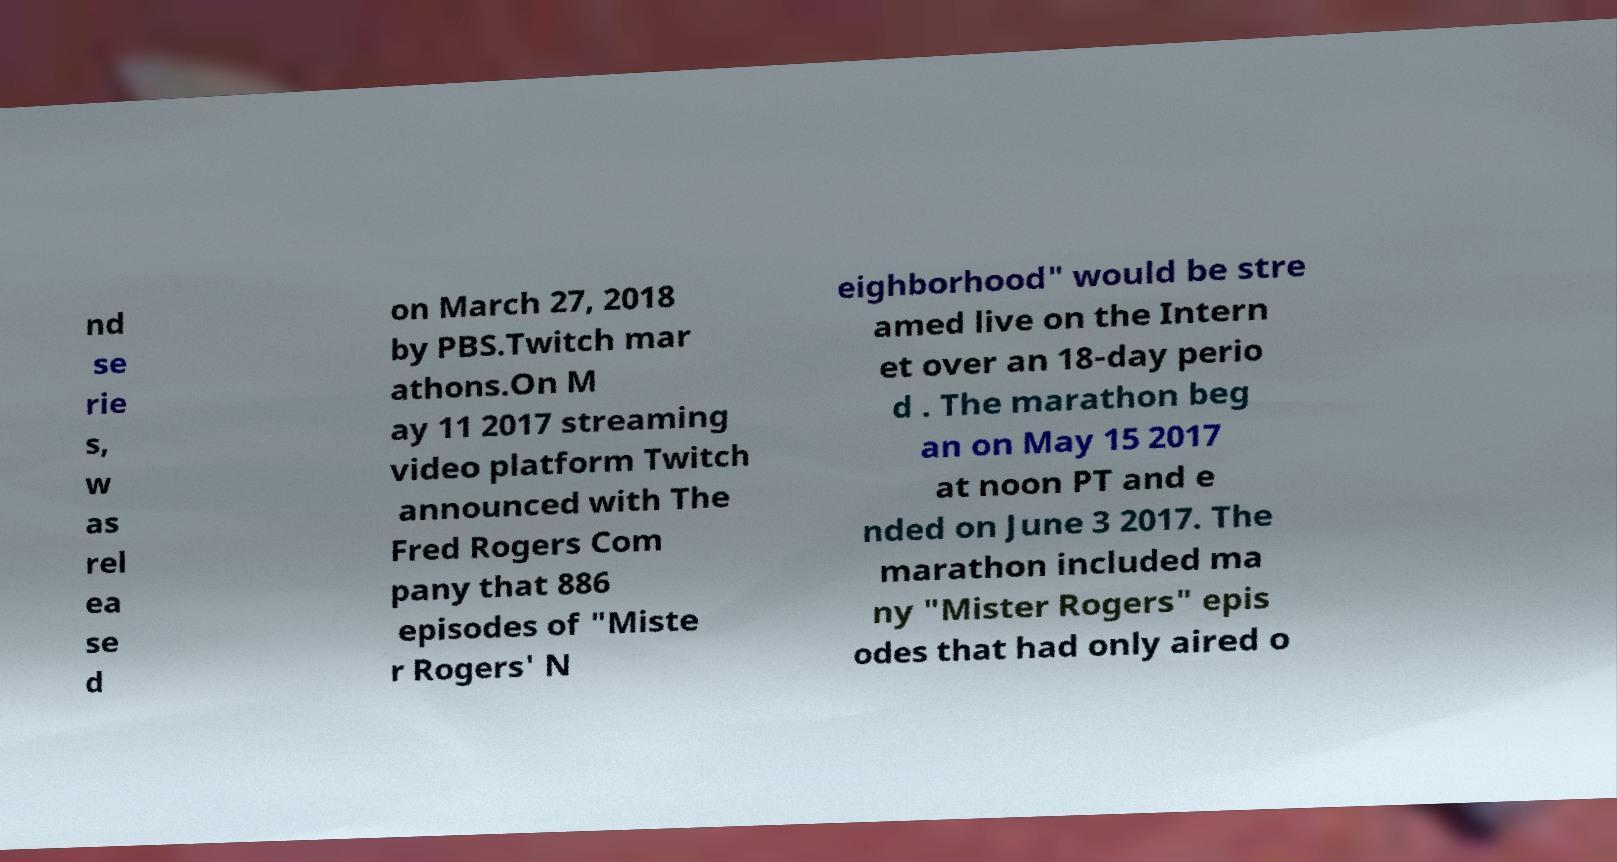I need the written content from this picture converted into text. Can you do that? nd se rie s, w as rel ea se d on March 27, 2018 by PBS.Twitch mar athons.On M ay 11 2017 streaming video platform Twitch announced with The Fred Rogers Com pany that 886 episodes of "Miste r Rogers' N eighborhood" would be stre amed live on the Intern et over an 18-day perio d . The marathon beg an on May 15 2017 at noon PT and e nded on June 3 2017. The marathon included ma ny "Mister Rogers" epis odes that had only aired o 